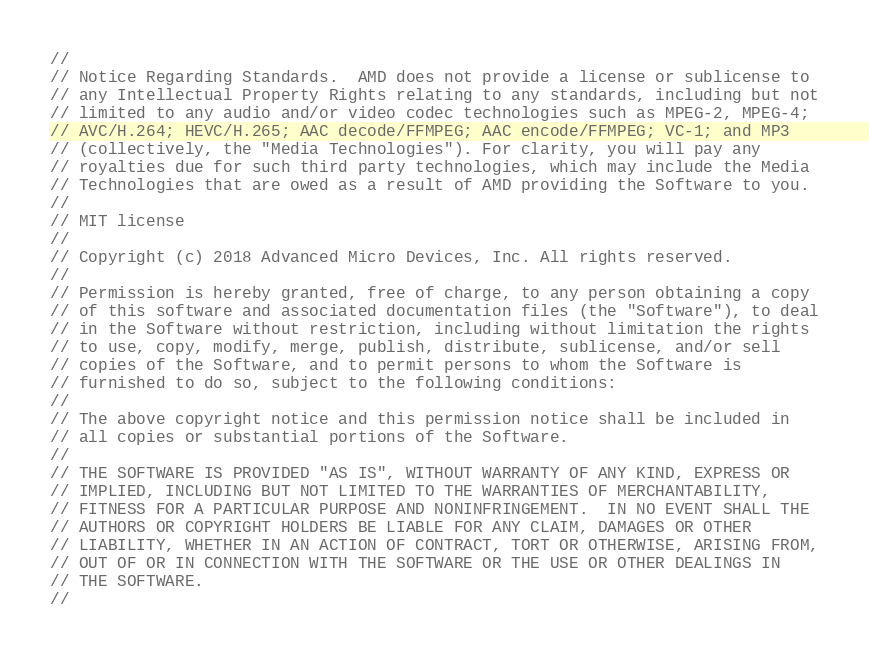Convert code to text. <code><loc_0><loc_0><loc_500><loc_500><_C++_>// 
// Notice Regarding Standards.  AMD does not provide a license or sublicense to
// any Intellectual Property Rights relating to any standards, including but not
// limited to any audio and/or video codec technologies such as MPEG-2, MPEG-4;
// AVC/H.264; HEVC/H.265; AAC decode/FFMPEG; AAC encode/FFMPEG; VC-1; and MP3
// (collectively, the "Media Technologies"). For clarity, you will pay any
// royalties due for such third party technologies, which may include the Media
// Technologies that are owed as a result of AMD providing the Software to you.
// 
// MIT license 
// 
// Copyright (c) 2018 Advanced Micro Devices, Inc. All rights reserved.
//
// Permission is hereby granted, free of charge, to any person obtaining a copy
// of this software and associated documentation files (the "Software"), to deal
// in the Software without restriction, including without limitation the rights
// to use, copy, modify, merge, publish, distribute, sublicense, and/or sell
// copies of the Software, and to permit persons to whom the Software is
// furnished to do so, subject to the following conditions:
//
// The above copyright notice and this permission notice shall be included in
// all copies or substantial portions of the Software.
//
// THE SOFTWARE IS PROVIDED "AS IS", WITHOUT WARRANTY OF ANY KIND, EXPRESS OR
// IMPLIED, INCLUDING BUT NOT LIMITED TO THE WARRANTIES OF MERCHANTABILITY,
// FITNESS FOR A PARTICULAR PURPOSE AND NONINFRINGEMENT.  IN NO EVENT SHALL THE
// AUTHORS OR COPYRIGHT HOLDERS BE LIABLE FOR ANY CLAIM, DAMAGES OR OTHER
// LIABILITY, WHETHER IN AN ACTION OF CONTRACT, TORT OR OTHERWISE, ARISING FROM,
// OUT OF OR IN CONNECTION WITH THE SOFTWARE OR THE USE OR OTHER DEALINGS IN
// THE SOFTWARE.
//
</code> 